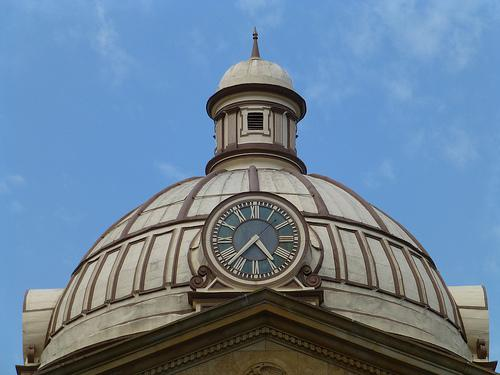Question: where is the clock?
Choices:
A. Kitchen wall.
B. In livingroom.
C. In the bedroom.
D. In front of the building.
Answer with the letter. Answer: D Question: what numbers is the hour hand between?
Choices:
A. Two and Three.
B. Ten and Eleven.
C. Six and Seven.
D. Four and Five.
Answer with the letter. Answer: D Question: what shape is the clock tower?
Choices:
A. Square.
B. Round.
C. Dome-Shaped.
D. Octagon.
Answer with the letter. Answer: C 